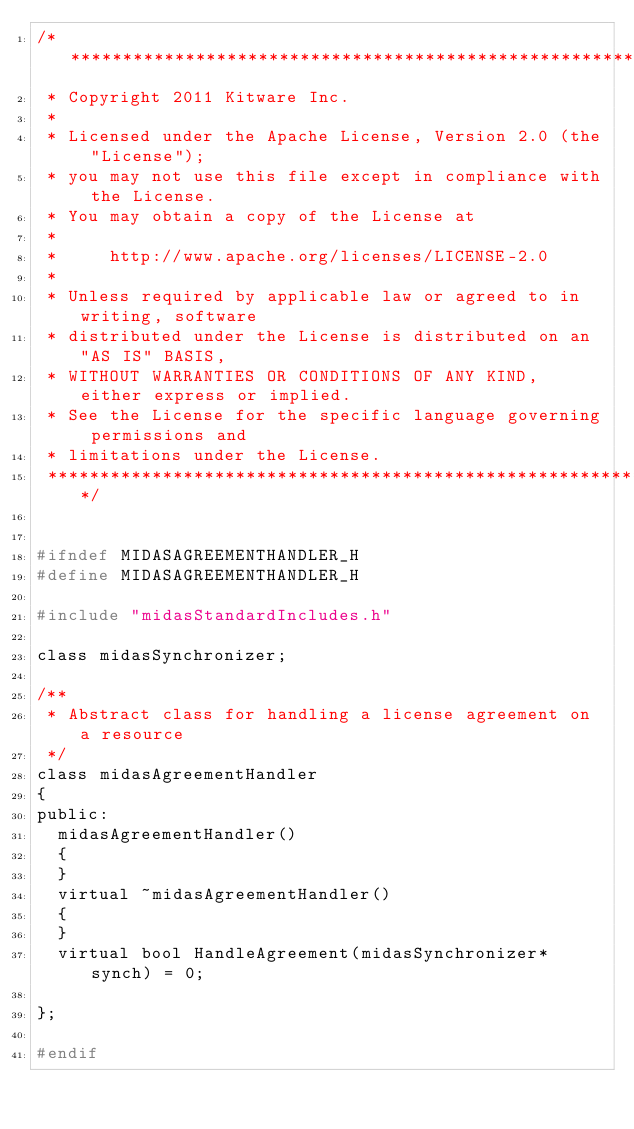<code> <loc_0><loc_0><loc_500><loc_500><_C_>/******************************************************************************
 * Copyright 2011 Kitware Inc.
 *
 * Licensed under the Apache License, Version 2.0 (the "License");
 * you may not use this file except in compliance with the License.
 * You may obtain a copy of the License at
 *
 *     http://www.apache.org/licenses/LICENSE-2.0
 *
 * Unless required by applicable law or agreed to in writing, software
 * distributed under the License is distributed on an "AS IS" BASIS,
 * WITHOUT WARRANTIES OR CONDITIONS OF ANY KIND, either express or implied.
 * See the License for the specific language governing permissions and
 * limitations under the License.
 *****************************************************************************/


#ifndef MIDASAGREEMENTHANDLER_H
#define MIDASAGREEMENTHANDLER_H

#include "midasStandardIncludes.h"

class midasSynchronizer;

/**
 * Abstract class for handling a license agreement on a resource
 */
class midasAgreementHandler
{
public:
  midasAgreementHandler()
  {
  }
  virtual ~midasAgreementHandler()
  {
  }
  virtual bool HandleAgreement(midasSynchronizer* synch) = 0;

};

#endif
</code> 